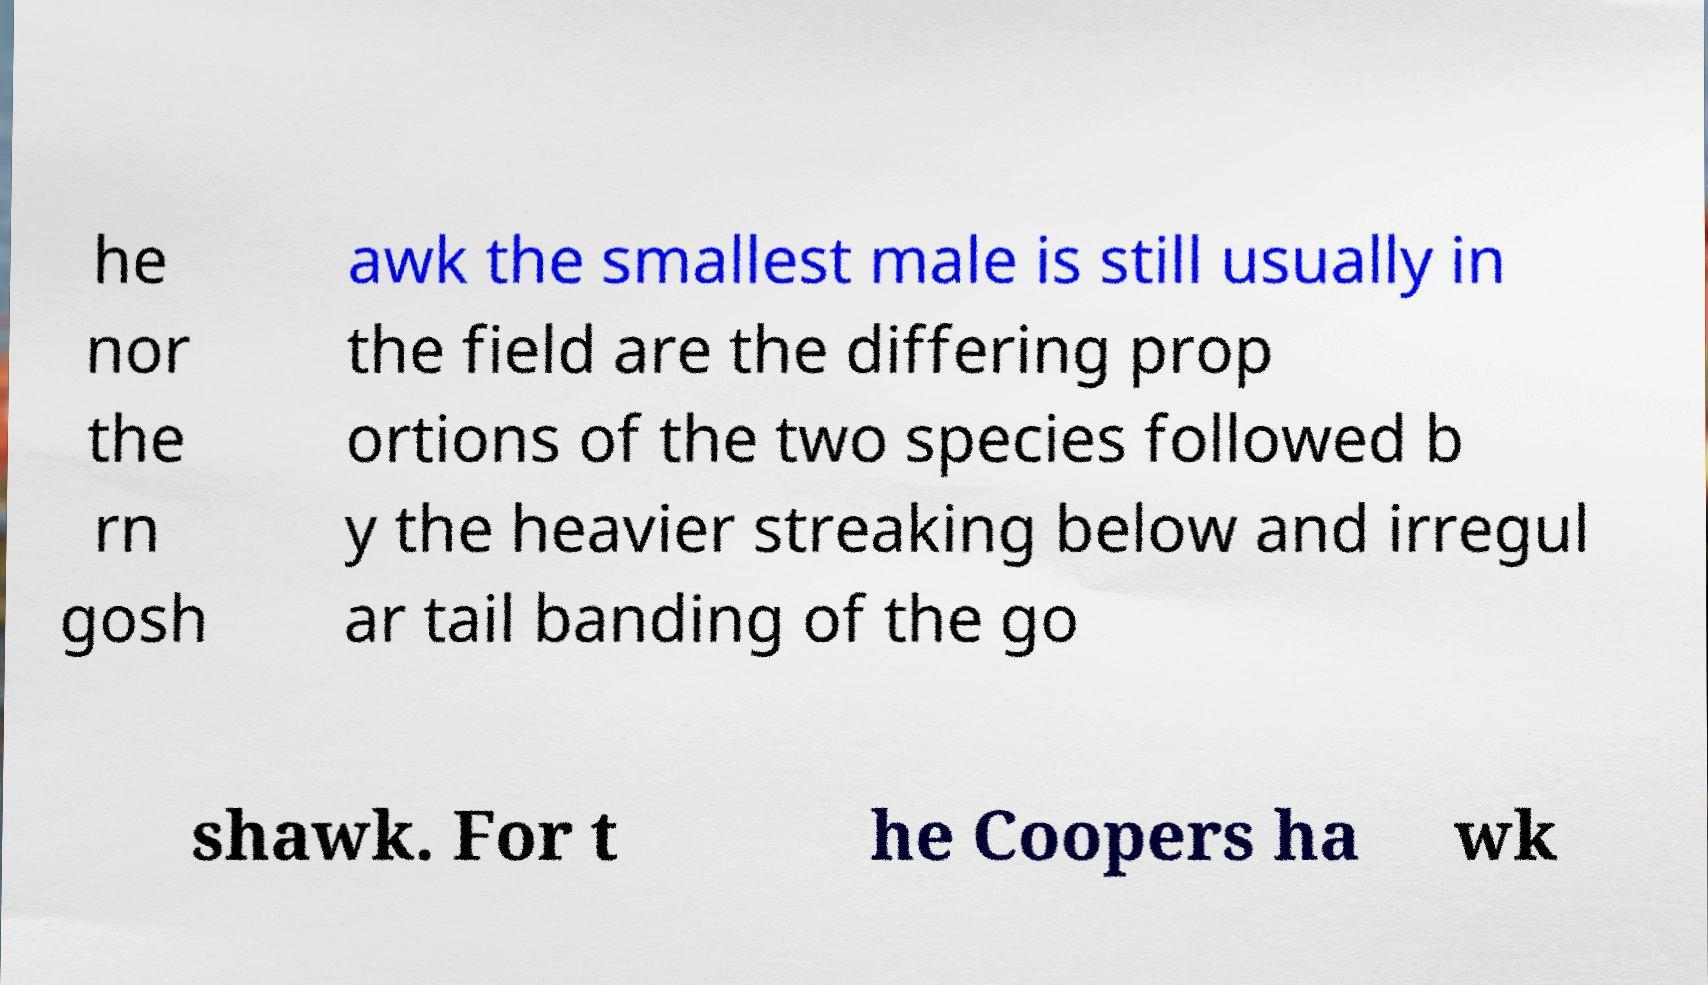There's text embedded in this image that I need extracted. Can you transcribe it verbatim? he nor the rn gosh awk the smallest male is still usually in the field are the differing prop ortions of the two species followed b y the heavier streaking below and irregul ar tail banding of the go shawk. For t he Coopers ha wk 